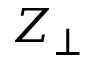<formula> <loc_0><loc_0><loc_500><loc_500>Z _ { \perp }</formula> 